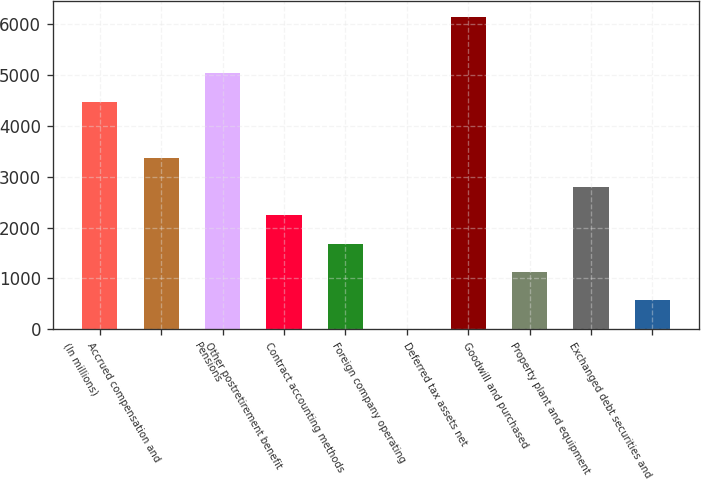Convert chart to OTSL. <chart><loc_0><loc_0><loc_500><loc_500><bar_chart><fcel>(In millions)<fcel>Accrued compensation and<fcel>Pensions<fcel>Other postretirement benefit<fcel>Contract accounting methods<fcel>Foreign company operating<fcel>Deferred tax assets net<fcel>Goodwill and purchased<fcel>Property plant and equipment<fcel>Exchanged debt securities and<nl><fcel>4474.8<fcel>3359.6<fcel>5032.4<fcel>2244.4<fcel>1686.8<fcel>14<fcel>6147.6<fcel>1129.2<fcel>2802<fcel>571.6<nl></chart> 